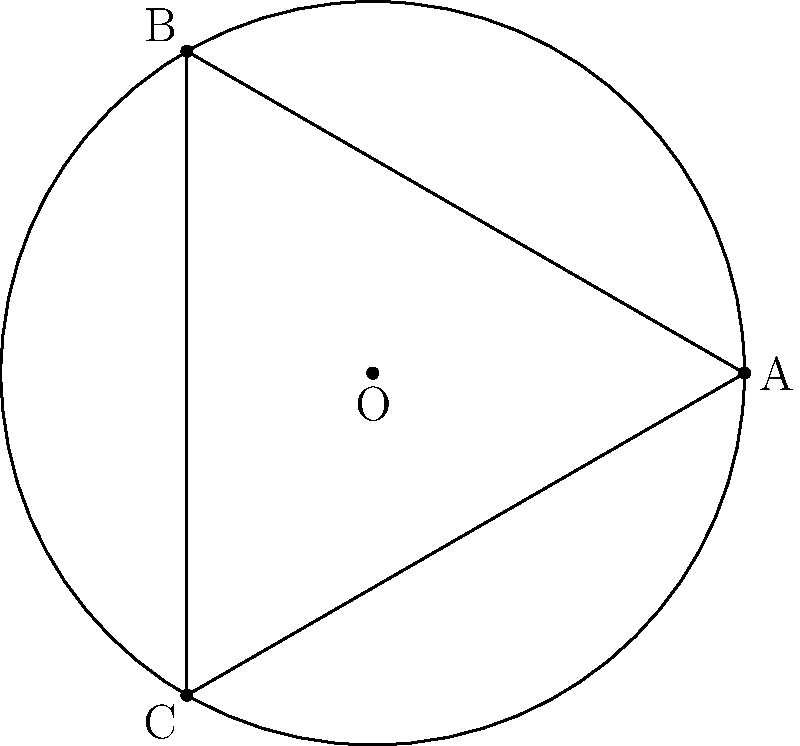In designing an unconventional spherical ceiling pattern, you decide to use a triangular motif based on great circles. If the radius of the sphere is $r$ and the triangle's vertices lie on the equator at 120° intervals, what is the area of this spherical triangle in terms of $r$? To solve this problem, we'll use the principles of spherical geometry:

1. In spherical geometry, the sum of angles in a triangle is greater than 180°. The excess is proportional to the area of the triangle.

2. For a triangle on a sphere with radius $r$, the area $A$ is given by the formula:
   $$A = r^2(A + B + C - \pi)$$
   where $A$, $B$, and $C$ are the angles of the triangle in radians.

3. In this case, we have an equilateral triangle with vertices 120° apart on the equator. This means each angle of the triangle is also 120° or $\frac{2\pi}{3}$ radians.

4. Substituting into the formula:
   $$A = r^2(\frac{2\pi}{3} + \frac{2\pi}{3} + \frac{2\pi}{3} - \pi)$$

5. Simplifying:
   $$A = r^2(2\pi - \pi) = r^2\pi$$

Therefore, the area of the spherical triangle is $\pi r^2$.
Answer: $\pi r^2$ 